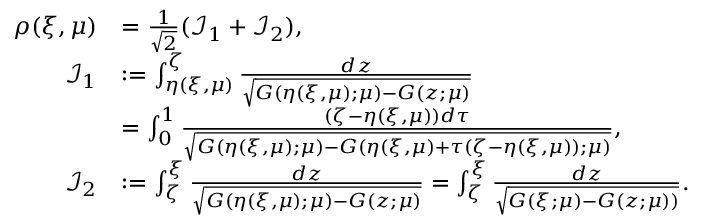<formula> <loc_0><loc_0><loc_500><loc_500>\begin{array} { r l } { \rho ( \xi , \mu ) } & { = \frac { 1 } \sqrt { 2 } } ( { \mathcal { I } } _ { 1 } + { \mathcal { I } } _ { 2 } ) , } \\ { { \mathcal { I } } _ { 1 } } & { \colon = \int _ { \eta ( \xi , \mu ) } ^ { \zeta } \frac { d z } { \sqrt { G ( \eta ( \xi , \mu ) ; \mu ) - G ( z ; \mu ) } } } \\ & { = \int _ { 0 } ^ { 1 } \frac { ( \zeta - \eta ( \xi , \mu ) ) d \tau } { \sqrt { G ( \eta ( \xi , \mu ) ; \mu ) - G ( \eta ( \xi , \mu ) + \tau ( \zeta - \eta ( \xi , \mu ) ) ; \mu ) } } , } \\ { { \mathcal { I } } _ { 2 } } & { \colon = \int _ { \zeta } ^ { \xi } \frac { d z } { \sqrt { G ( { \eta ( \xi , \mu ) } ; \mu ) - G ( z ; \mu ) } } = \int _ { \zeta } ^ { \xi } \frac { d z } { \sqrt { G ( \xi ; \mu ) - G ( z ; \mu ) ) } } . } \end{array}</formula> 